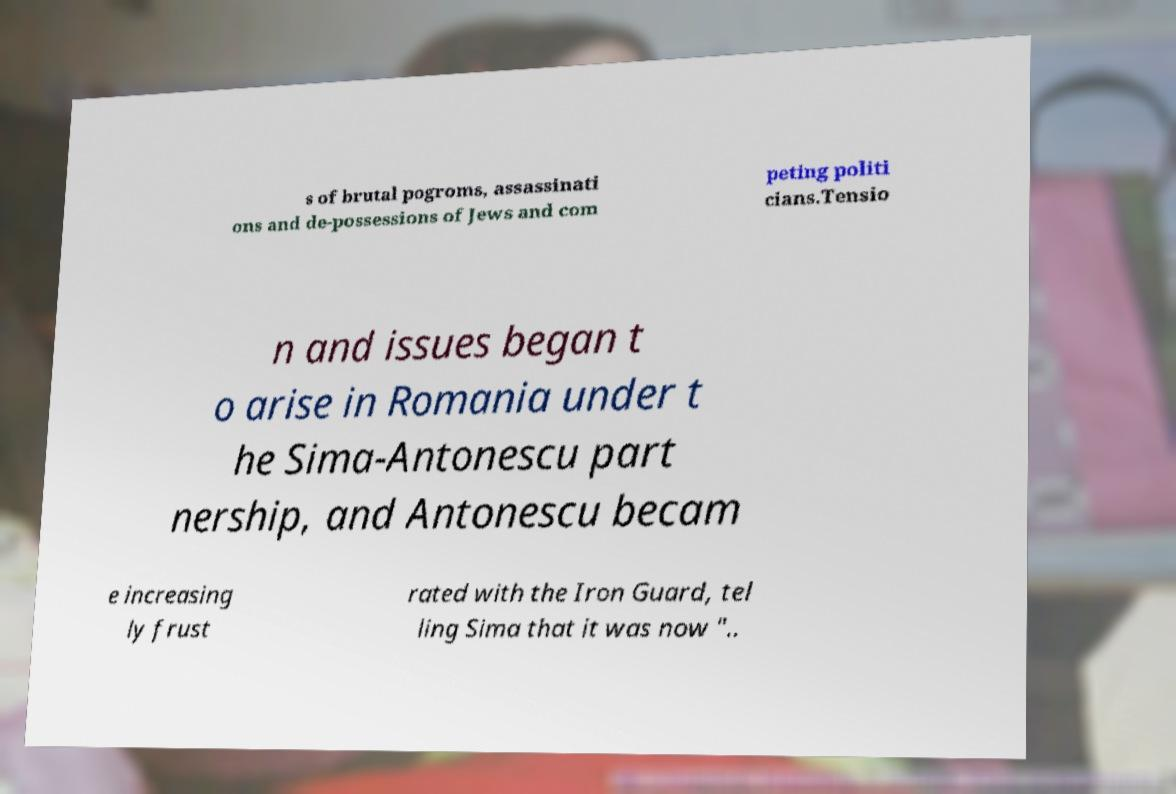Can you read and provide the text displayed in the image?This photo seems to have some interesting text. Can you extract and type it out for me? s of brutal pogroms, assassinati ons and de-possessions of Jews and com peting politi cians.Tensio n and issues began t o arise in Romania under t he Sima-Antonescu part nership, and Antonescu becam e increasing ly frust rated with the Iron Guard, tel ling Sima that it was now ".. 